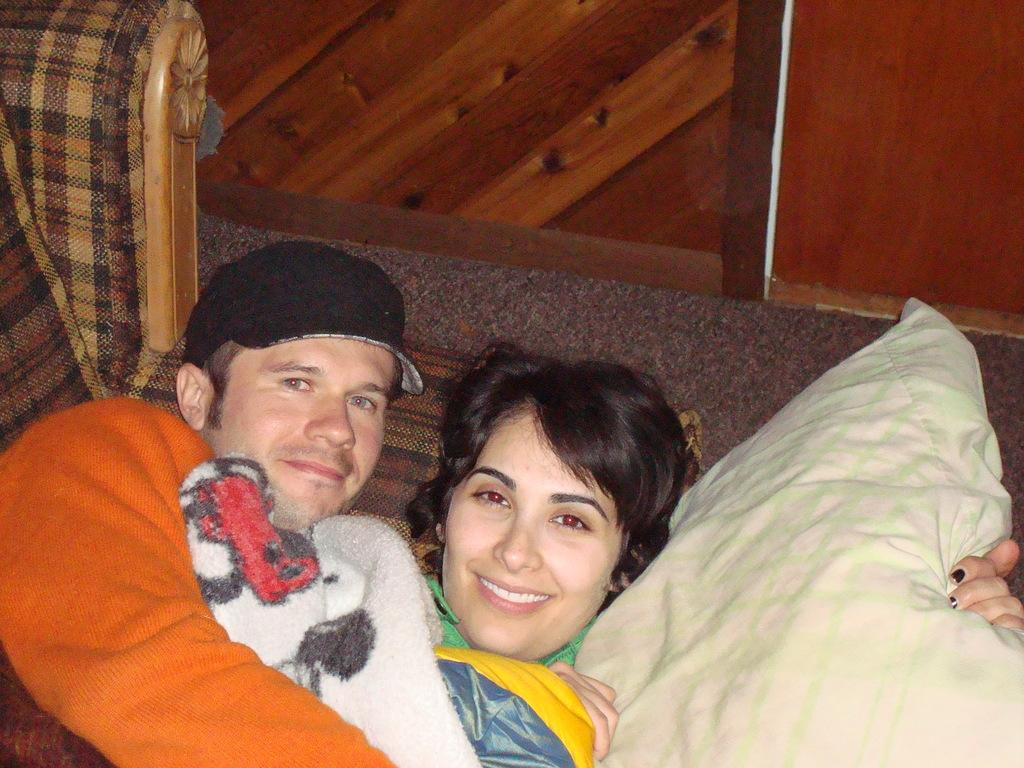How many people are in the foreground of the picture? There are two persons in the foreground of the picture. What are the persons doing in the image? The persons appear to be lying on a bed. Can you describe any specific objects in the image? Yes, there is a pillow in the right corner of the image. What else can be seen in the background of the image? There are other objects visible in the background of the image. What is the topic of the argument between the two persons in the image? There is no argument present in the image; the persons appear to be lying on a bed. How many oranges are visible in the image? There are no oranges present in the image. 